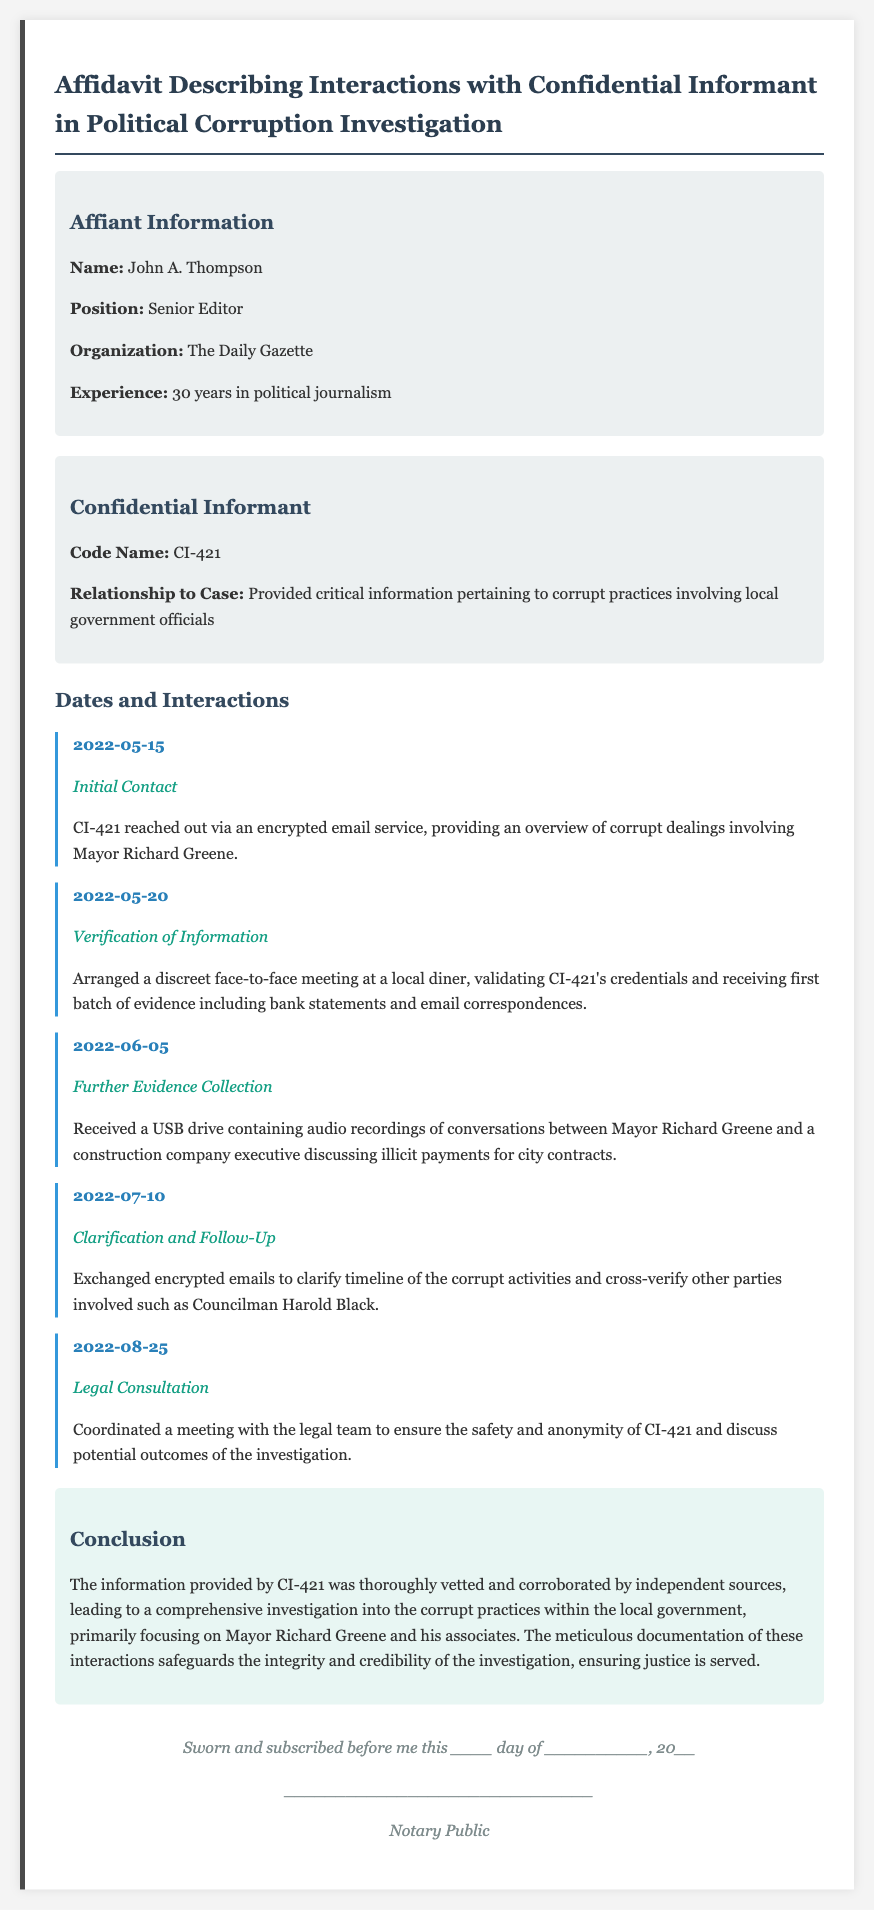What is the name of the affiant? The affiant's name is listed at the beginning of the document under Affiant Information.
Answer: John A. Thompson What is the code name of the confidential informant? The confidential informant's code name is specified under the Confidential Informant section.
Answer: CI-421 On what date did the initial contact with CI-421 occur? The date of the initial contact is detailed in the Dates and Interactions section.
Answer: 2022-05-15 What type of evidence was received on June 5, 2022? The document outlines the evidence received on this date in the Further Evidence Collection section.
Answer: USB drive containing audio recordings Who was involved in the illicit payment discussions according to the evidence? This information can be found in the Further Evidence Collection section with details on the conversations.
Answer: Mayor Richard Greene and a construction company executive What date was the legal consultation coordinated? The date for the meeting with the legal team is mentioned in the Dates and Interactions section.
Answer: 2022-08-25 What was the main focus of the investigation? The conclusion section summarizes the main focus of the investigation listed at the end of the document.
Answer: Corrupt practices within the local government How many years has John A. Thompson worked in political journalism? The number of years is provided in the Affiant Information section.
Answer: 30 years What was the nature of the interaction on May 20, 2022? The nature is specified in the Dates and Interactions section regarding the meeting with CI-421.
Answer: Verification of Information 